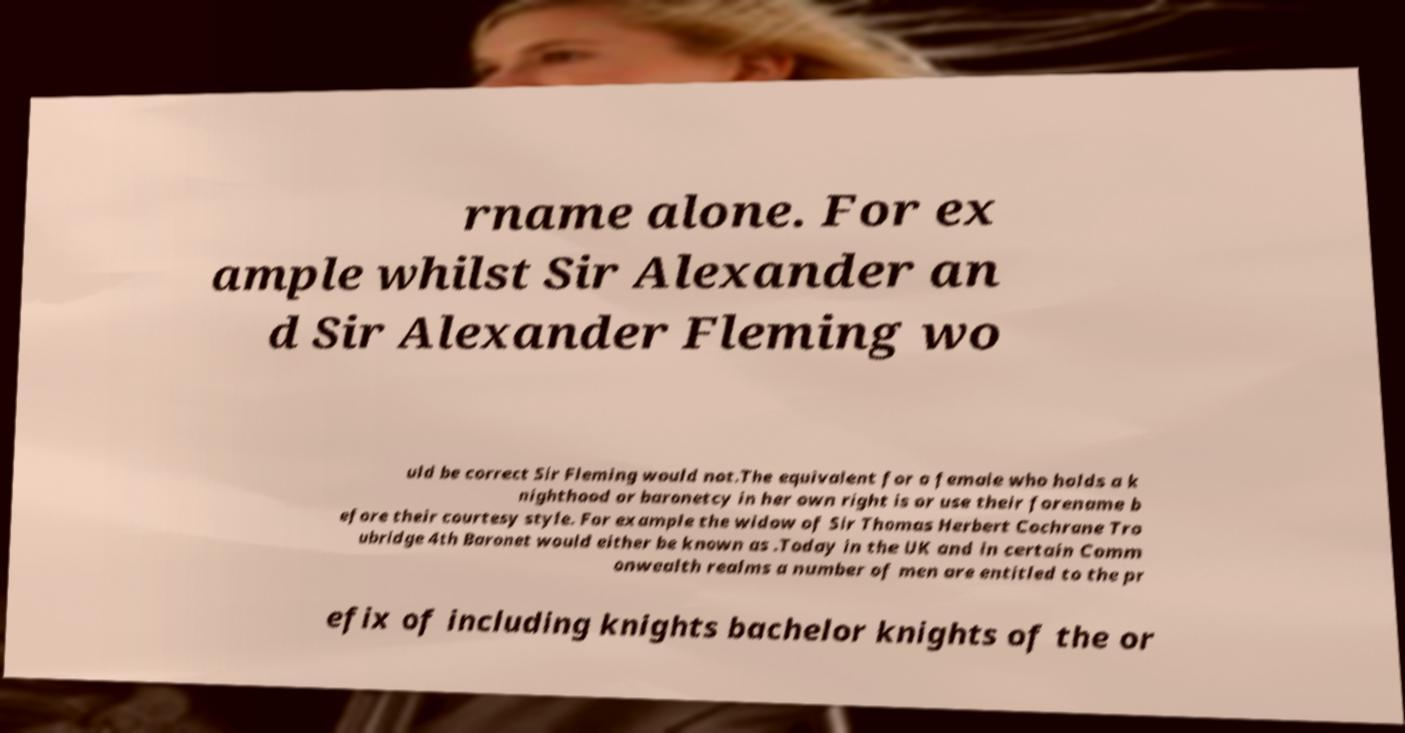What messages or text are displayed in this image? I need them in a readable, typed format. rname alone. For ex ample whilst Sir Alexander an d Sir Alexander Fleming wo uld be correct Sir Fleming would not.The equivalent for a female who holds a k nighthood or baronetcy in her own right is or use their forename b efore their courtesy style. For example the widow of Sir Thomas Herbert Cochrane Tro ubridge 4th Baronet would either be known as .Today in the UK and in certain Comm onwealth realms a number of men are entitled to the pr efix of including knights bachelor knights of the or 